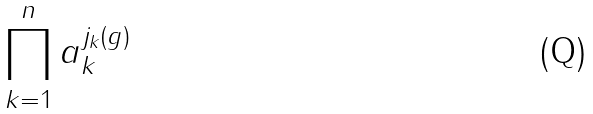Convert formula to latex. <formula><loc_0><loc_0><loc_500><loc_500>\prod _ { k = 1 } ^ { n } a _ { k } ^ { j _ { k } ( g ) }</formula> 